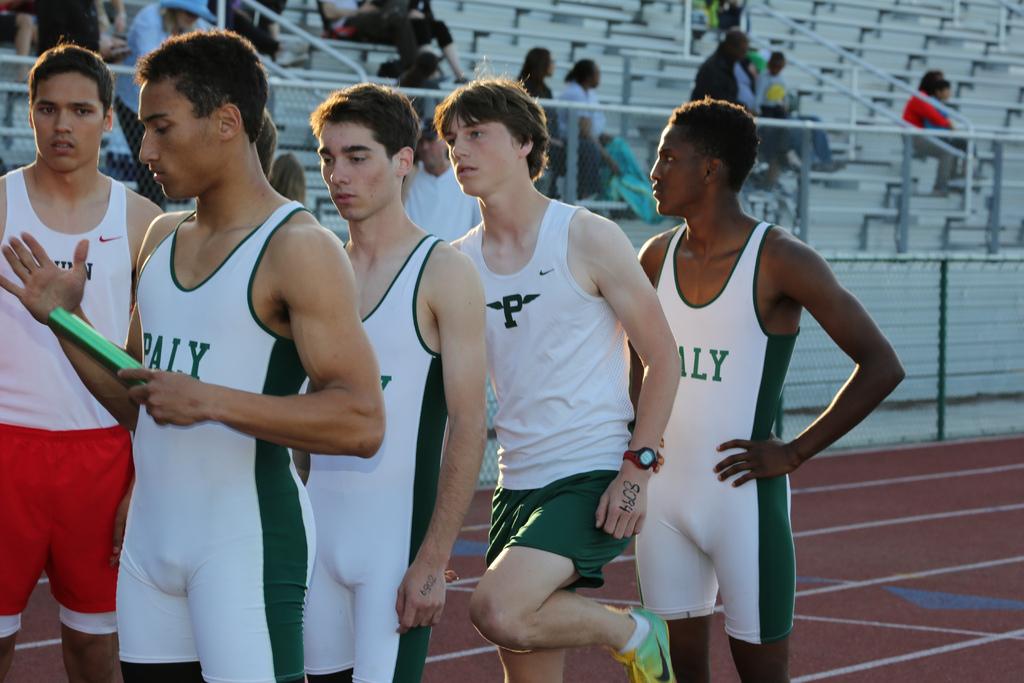What is the green team?
Give a very brief answer. Paly. 